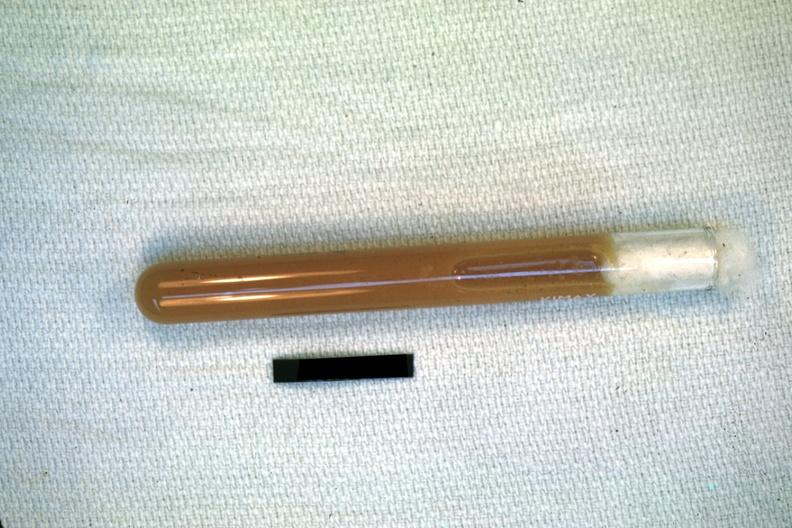s pus in test tube present?
Answer the question using a single word or phrase. Yes 